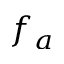<formula> <loc_0><loc_0><loc_500><loc_500>f _ { a }</formula> 